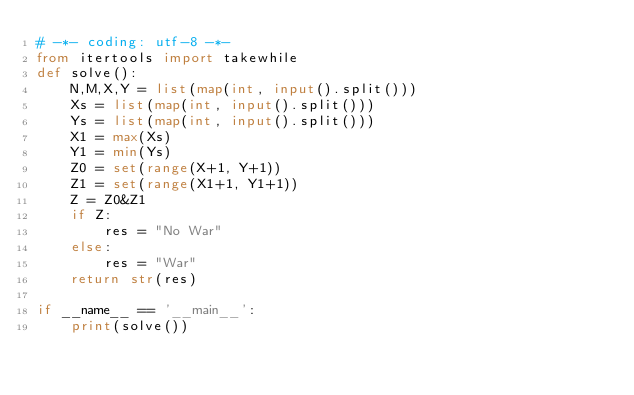Convert code to text. <code><loc_0><loc_0><loc_500><loc_500><_Python_># -*- coding: utf-8 -*-
from itertools import takewhile
def solve():
    N,M,X,Y = list(map(int, input().split()))
    Xs = list(map(int, input().split()))
    Ys = list(map(int, input().split()))
    X1 = max(Xs)
    Y1 = min(Ys)
    Z0 = set(range(X+1, Y+1))
    Z1 = set(range(X1+1, Y1+1))
    Z = Z0&Z1
    if Z:
        res = "No War"
    else:
        res = "War"
    return str(res)

if __name__ == '__main__':
    print(solve())</code> 